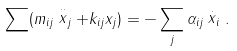Convert formula to latex. <formula><loc_0><loc_0><loc_500><loc_500>\sum ( m _ { i j } \stackrel { \cdot \cdot } { x } _ { j } + k _ { i j } x _ { j } ) = - \sum _ { j } \alpha _ { i j } \stackrel { . } { x } _ { i } .</formula> 